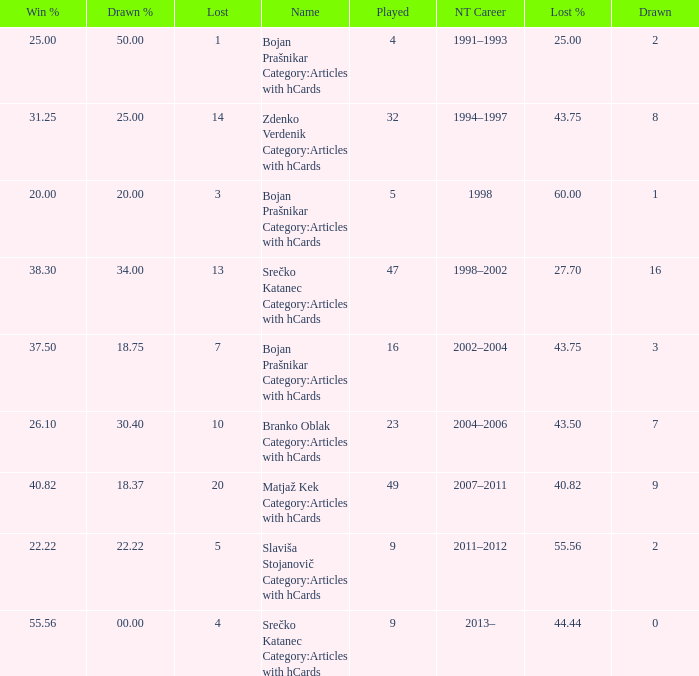How many values for Lost% occur when the value for drawn is 8 and less than 14 lost? 0.0. 